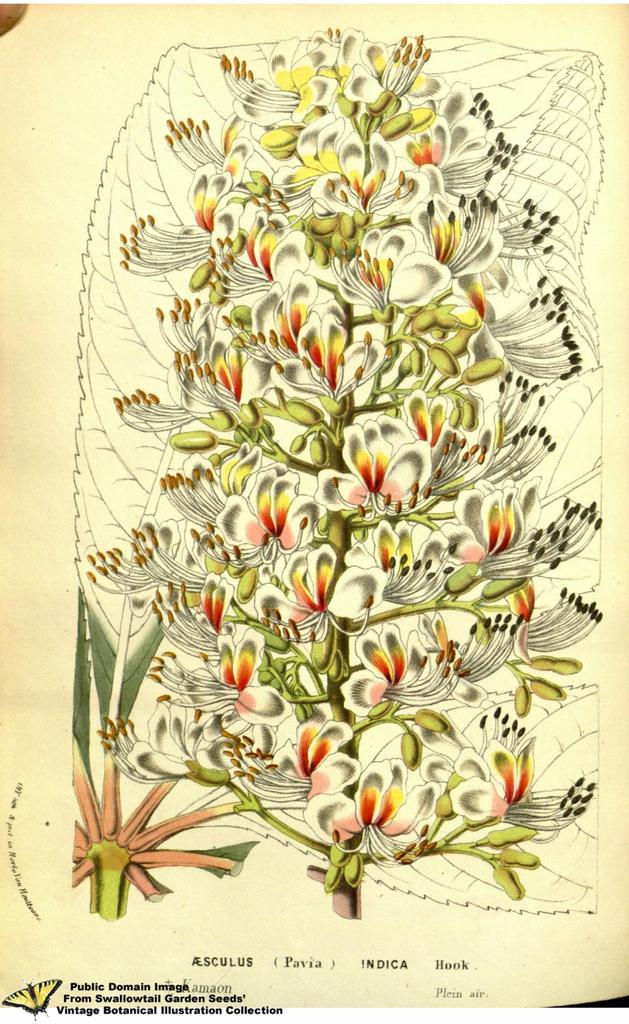In one or two sentences, can you explain what this image depicts? This image consists of a paper. On this paper there is a painting of a plant along with the flowers and buds. At the bottom of this image there is some text. 